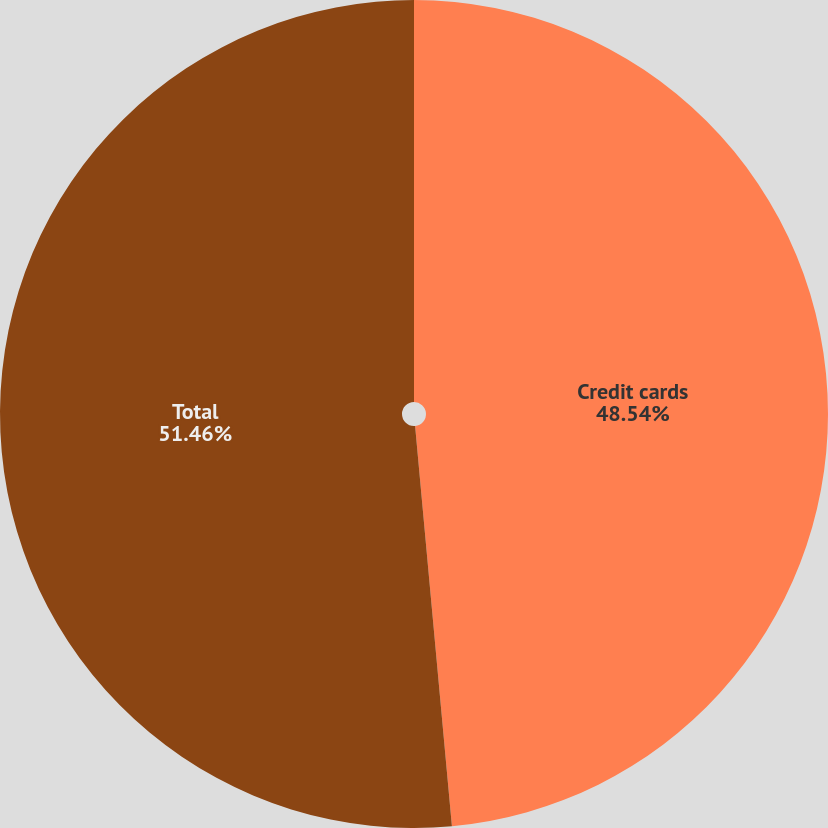Convert chart. <chart><loc_0><loc_0><loc_500><loc_500><pie_chart><fcel>Credit cards<fcel>Total<nl><fcel>48.54%<fcel>51.46%<nl></chart> 